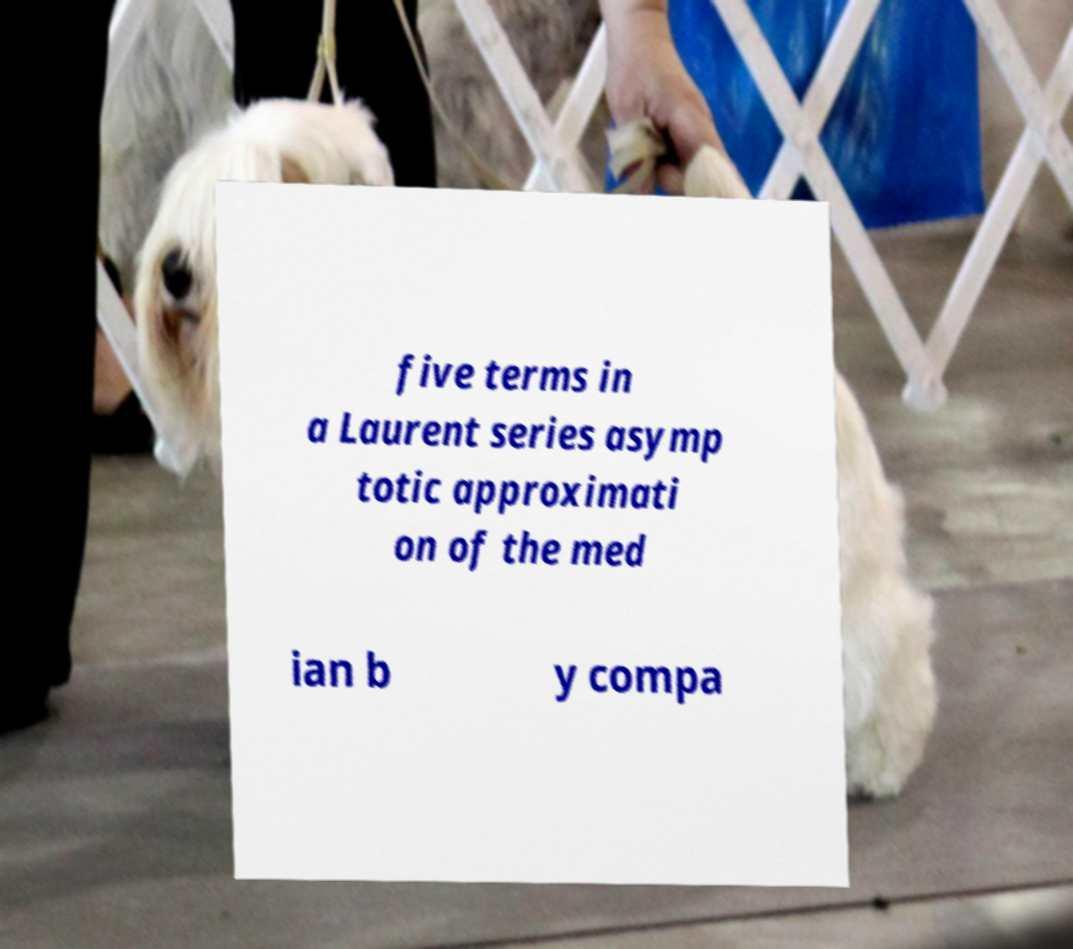Could you assist in decoding the text presented in this image and type it out clearly? five terms in a Laurent series asymp totic approximati on of the med ian b y compa 